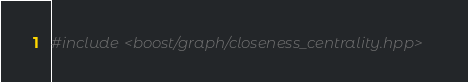<code> <loc_0><loc_0><loc_500><loc_500><_C++_>#include <boost/graph/closeness_centrality.hpp>
</code> 